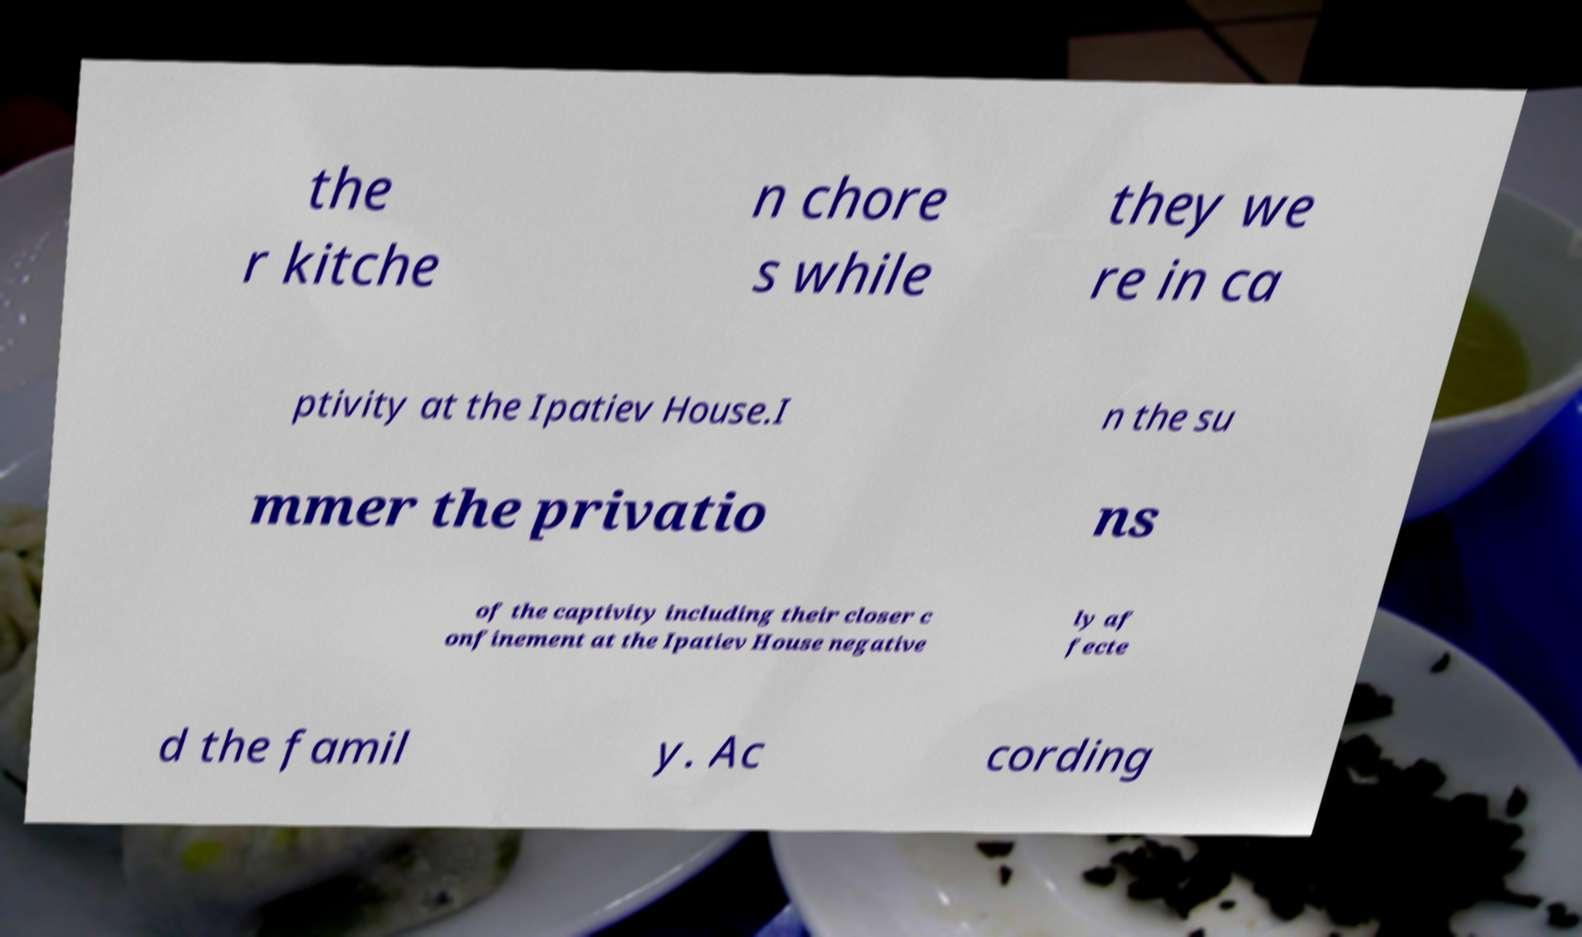Could you assist in decoding the text presented in this image and type it out clearly? the r kitche n chore s while they we re in ca ptivity at the Ipatiev House.I n the su mmer the privatio ns of the captivity including their closer c onfinement at the Ipatiev House negative ly af fecte d the famil y. Ac cording 